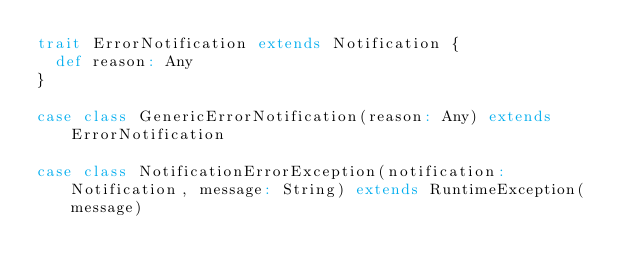Convert code to text. <code><loc_0><loc_0><loc_500><loc_500><_Scala_>trait ErrorNotification extends Notification {
  def reason: Any
}

case class GenericErrorNotification(reason: Any) extends ErrorNotification

case class NotificationErrorException(notification: Notification, message: String) extends RuntimeException(message)
</code> 